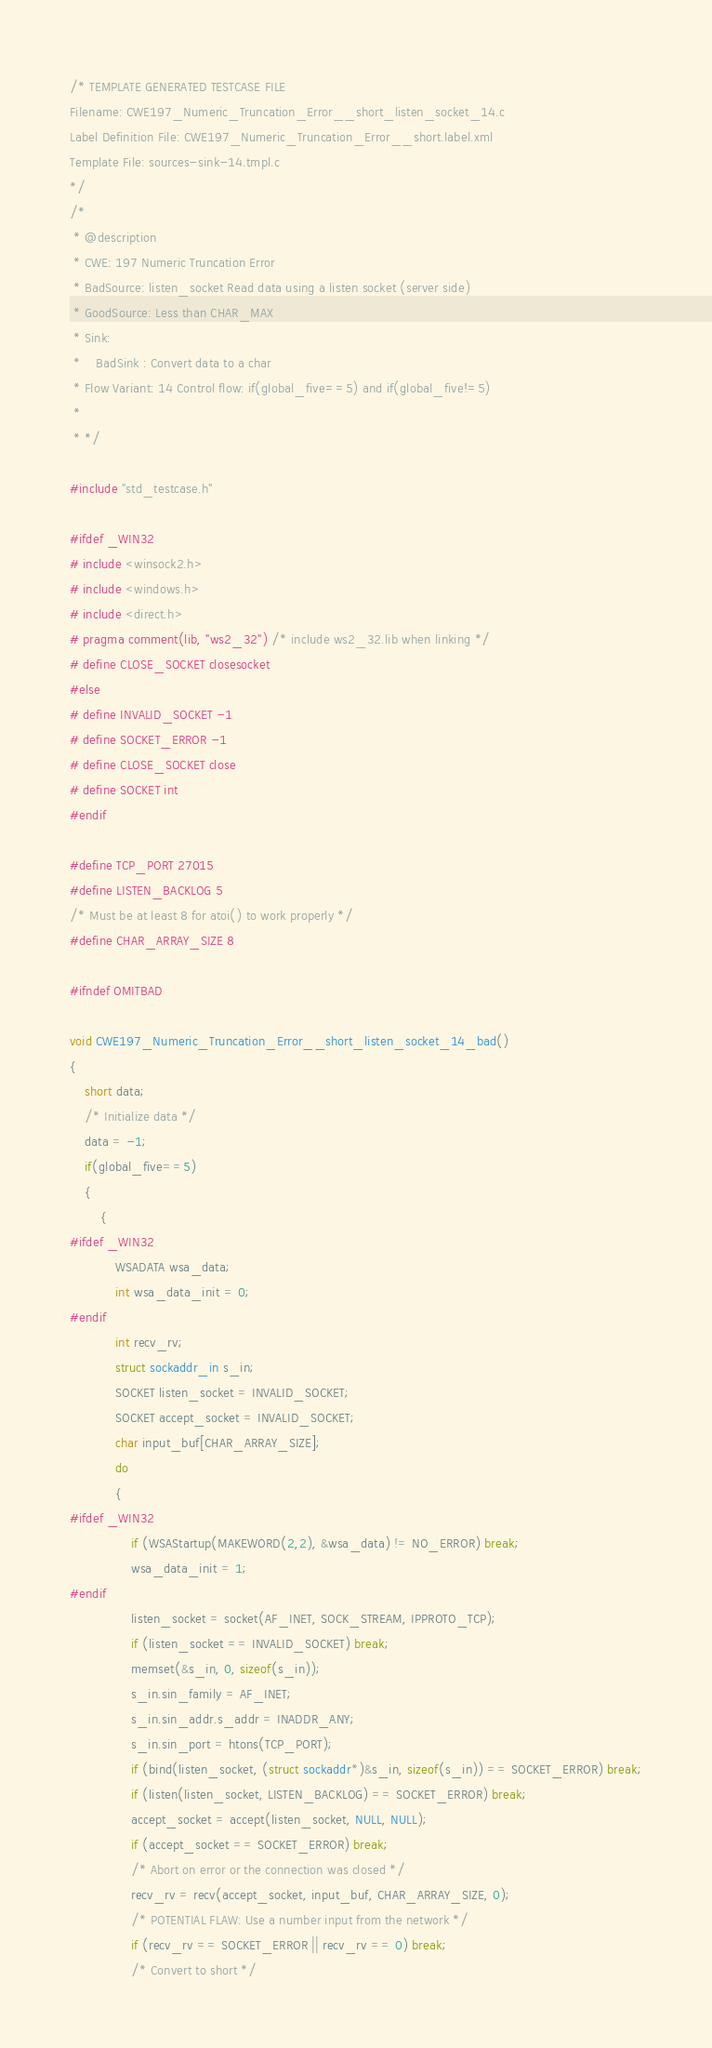Convert code to text. <code><loc_0><loc_0><loc_500><loc_500><_C_>/* TEMPLATE GENERATED TESTCASE FILE
Filename: CWE197_Numeric_Truncation_Error__short_listen_socket_14.c
Label Definition File: CWE197_Numeric_Truncation_Error__short.label.xml
Template File: sources-sink-14.tmpl.c
*/
/*
 * @description
 * CWE: 197 Numeric Truncation Error
 * BadSource: listen_socket Read data using a listen socket (server side)
 * GoodSource: Less than CHAR_MAX
 * Sink:
 *    BadSink : Convert data to a char
 * Flow Variant: 14 Control flow: if(global_five==5) and if(global_five!=5)
 *
 * */

#include "std_testcase.h"

#ifdef _WIN32
# include <winsock2.h>
# include <windows.h>
# include <direct.h>
# pragma comment(lib, "ws2_32") /* include ws2_32.lib when linking */
# define CLOSE_SOCKET closesocket
#else
# define INVALID_SOCKET -1
# define SOCKET_ERROR -1
# define CLOSE_SOCKET close
# define SOCKET int
#endif

#define TCP_PORT 27015
#define LISTEN_BACKLOG 5
/* Must be at least 8 for atoi() to work properly */
#define CHAR_ARRAY_SIZE 8

#ifndef OMITBAD

void CWE197_Numeric_Truncation_Error__short_listen_socket_14_bad()
{
    short data;
    /* Initialize data */
    data = -1;
    if(global_five==5)
    {
        {
#ifdef _WIN32
            WSADATA wsa_data;
            int wsa_data_init = 0;
#endif
            int recv_rv;
            struct sockaddr_in s_in;
            SOCKET listen_socket = INVALID_SOCKET;
            SOCKET accept_socket = INVALID_SOCKET;
            char input_buf[CHAR_ARRAY_SIZE];
            do
            {
#ifdef _WIN32
                if (WSAStartup(MAKEWORD(2,2), &wsa_data) != NO_ERROR) break;
                wsa_data_init = 1;
#endif
                listen_socket = socket(AF_INET, SOCK_STREAM, IPPROTO_TCP);
                if (listen_socket == INVALID_SOCKET) break;
                memset(&s_in, 0, sizeof(s_in));
                s_in.sin_family = AF_INET;
                s_in.sin_addr.s_addr = INADDR_ANY;
                s_in.sin_port = htons(TCP_PORT);
                if (bind(listen_socket, (struct sockaddr*)&s_in, sizeof(s_in)) == SOCKET_ERROR) break;
                if (listen(listen_socket, LISTEN_BACKLOG) == SOCKET_ERROR) break;
                accept_socket = accept(listen_socket, NULL, NULL);
                if (accept_socket == SOCKET_ERROR) break;
                /* Abort on error or the connection was closed */
                recv_rv = recv(accept_socket, input_buf, CHAR_ARRAY_SIZE, 0);
                /* POTENTIAL FLAW: Use a number input from the network */
                if (recv_rv == SOCKET_ERROR || recv_rv == 0) break;
                /* Convert to short */</code> 